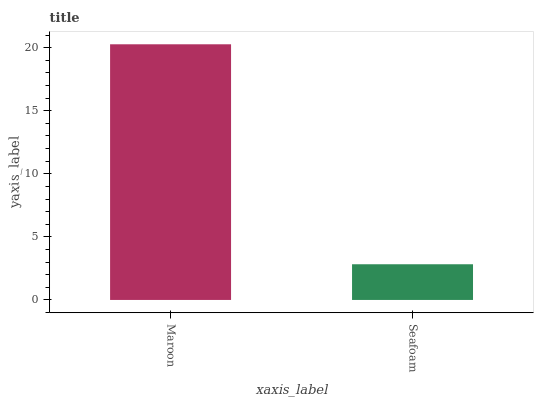Is Seafoam the minimum?
Answer yes or no. Yes. Is Maroon the maximum?
Answer yes or no. Yes. Is Seafoam the maximum?
Answer yes or no. No. Is Maroon greater than Seafoam?
Answer yes or no. Yes. Is Seafoam less than Maroon?
Answer yes or no. Yes. Is Seafoam greater than Maroon?
Answer yes or no. No. Is Maroon less than Seafoam?
Answer yes or no. No. Is Maroon the high median?
Answer yes or no. Yes. Is Seafoam the low median?
Answer yes or no. Yes. Is Seafoam the high median?
Answer yes or no. No. Is Maroon the low median?
Answer yes or no. No. 